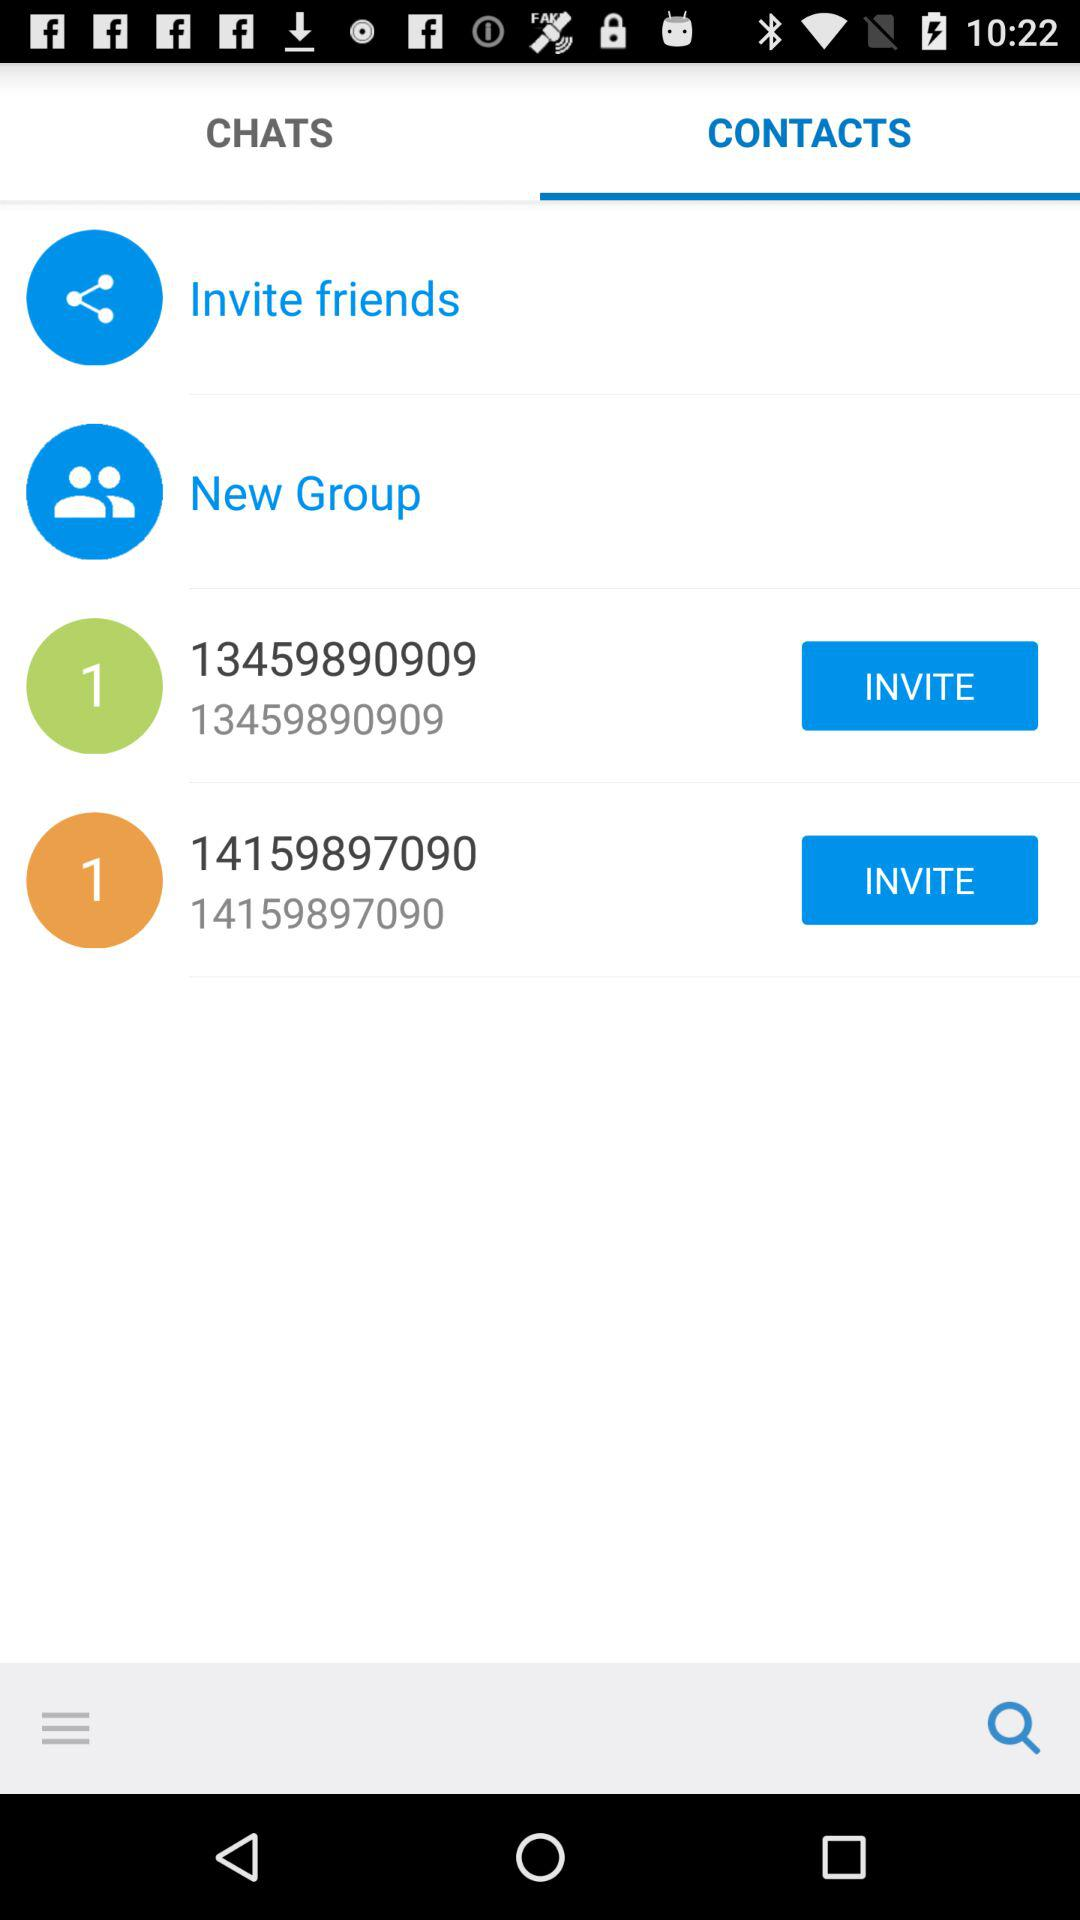Which tab is selected? The selected tab is "CONTACTS". 